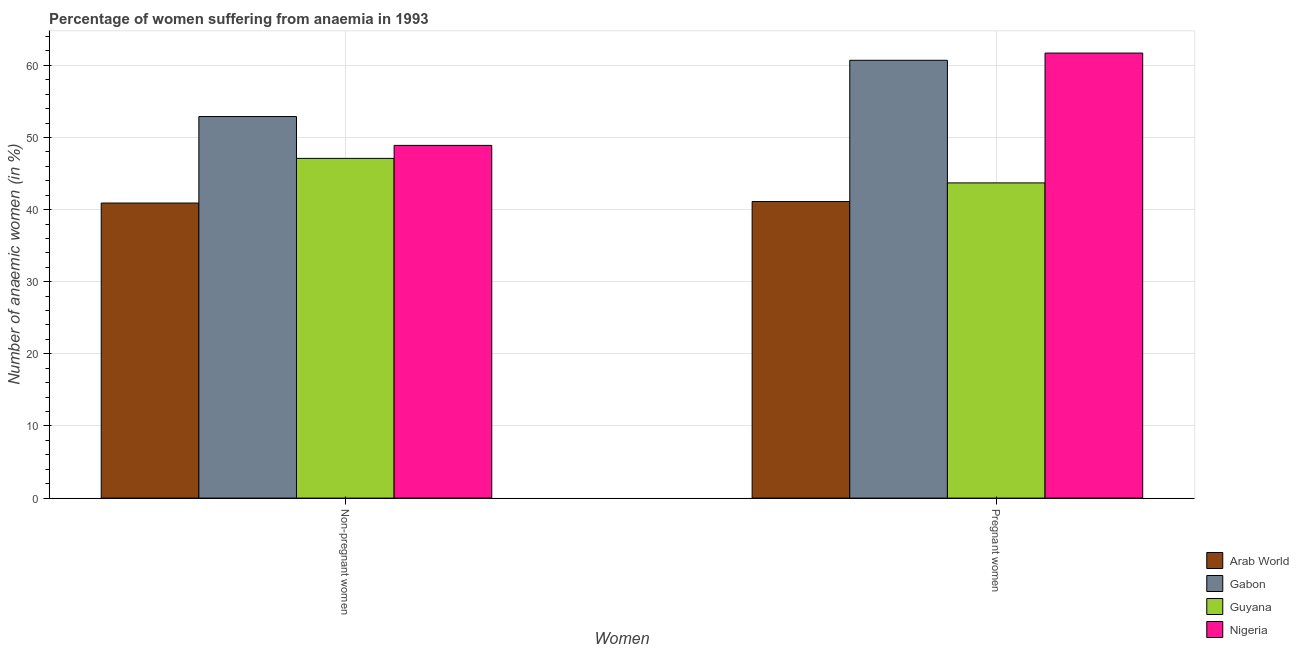Are the number of bars on each tick of the X-axis equal?
Offer a terse response. Yes. How many bars are there on the 2nd tick from the right?
Ensure brevity in your answer.  4. What is the label of the 1st group of bars from the left?
Keep it short and to the point. Non-pregnant women. What is the percentage of non-pregnant anaemic women in Arab World?
Your response must be concise. 40.91. Across all countries, what is the maximum percentage of non-pregnant anaemic women?
Provide a succinct answer. 52.9. Across all countries, what is the minimum percentage of non-pregnant anaemic women?
Provide a succinct answer. 40.91. In which country was the percentage of non-pregnant anaemic women maximum?
Provide a short and direct response. Gabon. In which country was the percentage of non-pregnant anaemic women minimum?
Give a very brief answer. Arab World. What is the total percentage of pregnant anaemic women in the graph?
Give a very brief answer. 207.22. What is the difference between the percentage of non-pregnant anaemic women in Guyana and that in Gabon?
Your answer should be very brief. -5.8. What is the difference between the percentage of pregnant anaemic women in Gabon and the percentage of non-pregnant anaemic women in Guyana?
Make the answer very short. 13.6. What is the average percentage of non-pregnant anaemic women per country?
Ensure brevity in your answer.  47.45. What is the difference between the percentage of pregnant anaemic women and percentage of non-pregnant anaemic women in Arab World?
Provide a succinct answer. 0.21. In how many countries, is the percentage of pregnant anaemic women greater than 30 %?
Give a very brief answer. 4. What is the ratio of the percentage of non-pregnant anaemic women in Arab World to that in Gabon?
Provide a short and direct response. 0.77. Is the percentage of pregnant anaemic women in Gabon less than that in Arab World?
Your answer should be very brief. No. In how many countries, is the percentage of non-pregnant anaemic women greater than the average percentage of non-pregnant anaemic women taken over all countries?
Keep it short and to the point. 2. What does the 2nd bar from the left in Pregnant women represents?
Offer a very short reply. Gabon. What does the 1st bar from the right in Pregnant women represents?
Provide a short and direct response. Nigeria. What is the difference between two consecutive major ticks on the Y-axis?
Your answer should be very brief. 10. Where does the legend appear in the graph?
Provide a short and direct response. Bottom right. How many legend labels are there?
Offer a terse response. 4. How are the legend labels stacked?
Offer a very short reply. Vertical. What is the title of the graph?
Offer a terse response. Percentage of women suffering from anaemia in 1993. What is the label or title of the X-axis?
Your answer should be very brief. Women. What is the label or title of the Y-axis?
Provide a short and direct response. Number of anaemic women (in %). What is the Number of anaemic women (in %) of Arab World in Non-pregnant women?
Provide a succinct answer. 40.91. What is the Number of anaemic women (in %) of Gabon in Non-pregnant women?
Ensure brevity in your answer.  52.9. What is the Number of anaemic women (in %) in Guyana in Non-pregnant women?
Your answer should be compact. 47.1. What is the Number of anaemic women (in %) in Nigeria in Non-pregnant women?
Your answer should be very brief. 48.9. What is the Number of anaemic women (in %) in Arab World in Pregnant women?
Give a very brief answer. 41.12. What is the Number of anaemic women (in %) in Gabon in Pregnant women?
Your answer should be very brief. 60.7. What is the Number of anaemic women (in %) of Guyana in Pregnant women?
Your answer should be compact. 43.7. What is the Number of anaemic women (in %) in Nigeria in Pregnant women?
Keep it short and to the point. 61.7. Across all Women, what is the maximum Number of anaemic women (in %) in Arab World?
Offer a very short reply. 41.12. Across all Women, what is the maximum Number of anaemic women (in %) of Gabon?
Your response must be concise. 60.7. Across all Women, what is the maximum Number of anaemic women (in %) in Guyana?
Keep it short and to the point. 47.1. Across all Women, what is the maximum Number of anaemic women (in %) of Nigeria?
Give a very brief answer. 61.7. Across all Women, what is the minimum Number of anaemic women (in %) of Arab World?
Your answer should be compact. 40.91. Across all Women, what is the minimum Number of anaemic women (in %) of Gabon?
Offer a very short reply. 52.9. Across all Women, what is the minimum Number of anaemic women (in %) in Guyana?
Your answer should be very brief. 43.7. Across all Women, what is the minimum Number of anaemic women (in %) of Nigeria?
Offer a terse response. 48.9. What is the total Number of anaemic women (in %) in Arab World in the graph?
Provide a short and direct response. 82.02. What is the total Number of anaemic women (in %) in Gabon in the graph?
Make the answer very short. 113.6. What is the total Number of anaemic women (in %) of Guyana in the graph?
Provide a succinct answer. 90.8. What is the total Number of anaemic women (in %) in Nigeria in the graph?
Keep it short and to the point. 110.6. What is the difference between the Number of anaemic women (in %) in Arab World in Non-pregnant women and that in Pregnant women?
Offer a terse response. -0.21. What is the difference between the Number of anaemic women (in %) in Gabon in Non-pregnant women and that in Pregnant women?
Make the answer very short. -7.8. What is the difference between the Number of anaemic women (in %) of Arab World in Non-pregnant women and the Number of anaemic women (in %) of Gabon in Pregnant women?
Your response must be concise. -19.79. What is the difference between the Number of anaemic women (in %) in Arab World in Non-pregnant women and the Number of anaemic women (in %) in Guyana in Pregnant women?
Offer a very short reply. -2.79. What is the difference between the Number of anaemic women (in %) in Arab World in Non-pregnant women and the Number of anaemic women (in %) in Nigeria in Pregnant women?
Make the answer very short. -20.79. What is the difference between the Number of anaemic women (in %) of Guyana in Non-pregnant women and the Number of anaemic women (in %) of Nigeria in Pregnant women?
Offer a terse response. -14.6. What is the average Number of anaemic women (in %) of Arab World per Women?
Your response must be concise. 41.01. What is the average Number of anaemic women (in %) in Gabon per Women?
Offer a terse response. 56.8. What is the average Number of anaemic women (in %) of Guyana per Women?
Offer a terse response. 45.4. What is the average Number of anaemic women (in %) in Nigeria per Women?
Offer a terse response. 55.3. What is the difference between the Number of anaemic women (in %) in Arab World and Number of anaemic women (in %) in Gabon in Non-pregnant women?
Your response must be concise. -11.99. What is the difference between the Number of anaemic women (in %) in Arab World and Number of anaemic women (in %) in Guyana in Non-pregnant women?
Give a very brief answer. -6.19. What is the difference between the Number of anaemic women (in %) of Arab World and Number of anaemic women (in %) of Nigeria in Non-pregnant women?
Provide a short and direct response. -7.99. What is the difference between the Number of anaemic women (in %) in Gabon and Number of anaemic women (in %) in Nigeria in Non-pregnant women?
Offer a terse response. 4. What is the difference between the Number of anaemic women (in %) of Arab World and Number of anaemic women (in %) of Gabon in Pregnant women?
Provide a succinct answer. -19.58. What is the difference between the Number of anaemic women (in %) of Arab World and Number of anaemic women (in %) of Guyana in Pregnant women?
Your response must be concise. -2.58. What is the difference between the Number of anaemic women (in %) of Arab World and Number of anaemic women (in %) of Nigeria in Pregnant women?
Offer a very short reply. -20.58. What is the ratio of the Number of anaemic women (in %) of Gabon in Non-pregnant women to that in Pregnant women?
Ensure brevity in your answer.  0.87. What is the ratio of the Number of anaemic women (in %) in Guyana in Non-pregnant women to that in Pregnant women?
Provide a succinct answer. 1.08. What is the ratio of the Number of anaemic women (in %) in Nigeria in Non-pregnant women to that in Pregnant women?
Provide a succinct answer. 0.79. What is the difference between the highest and the second highest Number of anaemic women (in %) of Arab World?
Give a very brief answer. 0.21. What is the difference between the highest and the second highest Number of anaemic women (in %) of Gabon?
Make the answer very short. 7.8. What is the difference between the highest and the second highest Number of anaemic women (in %) in Nigeria?
Your response must be concise. 12.8. What is the difference between the highest and the lowest Number of anaemic women (in %) in Arab World?
Your response must be concise. 0.21. What is the difference between the highest and the lowest Number of anaemic women (in %) of Nigeria?
Your answer should be compact. 12.8. 